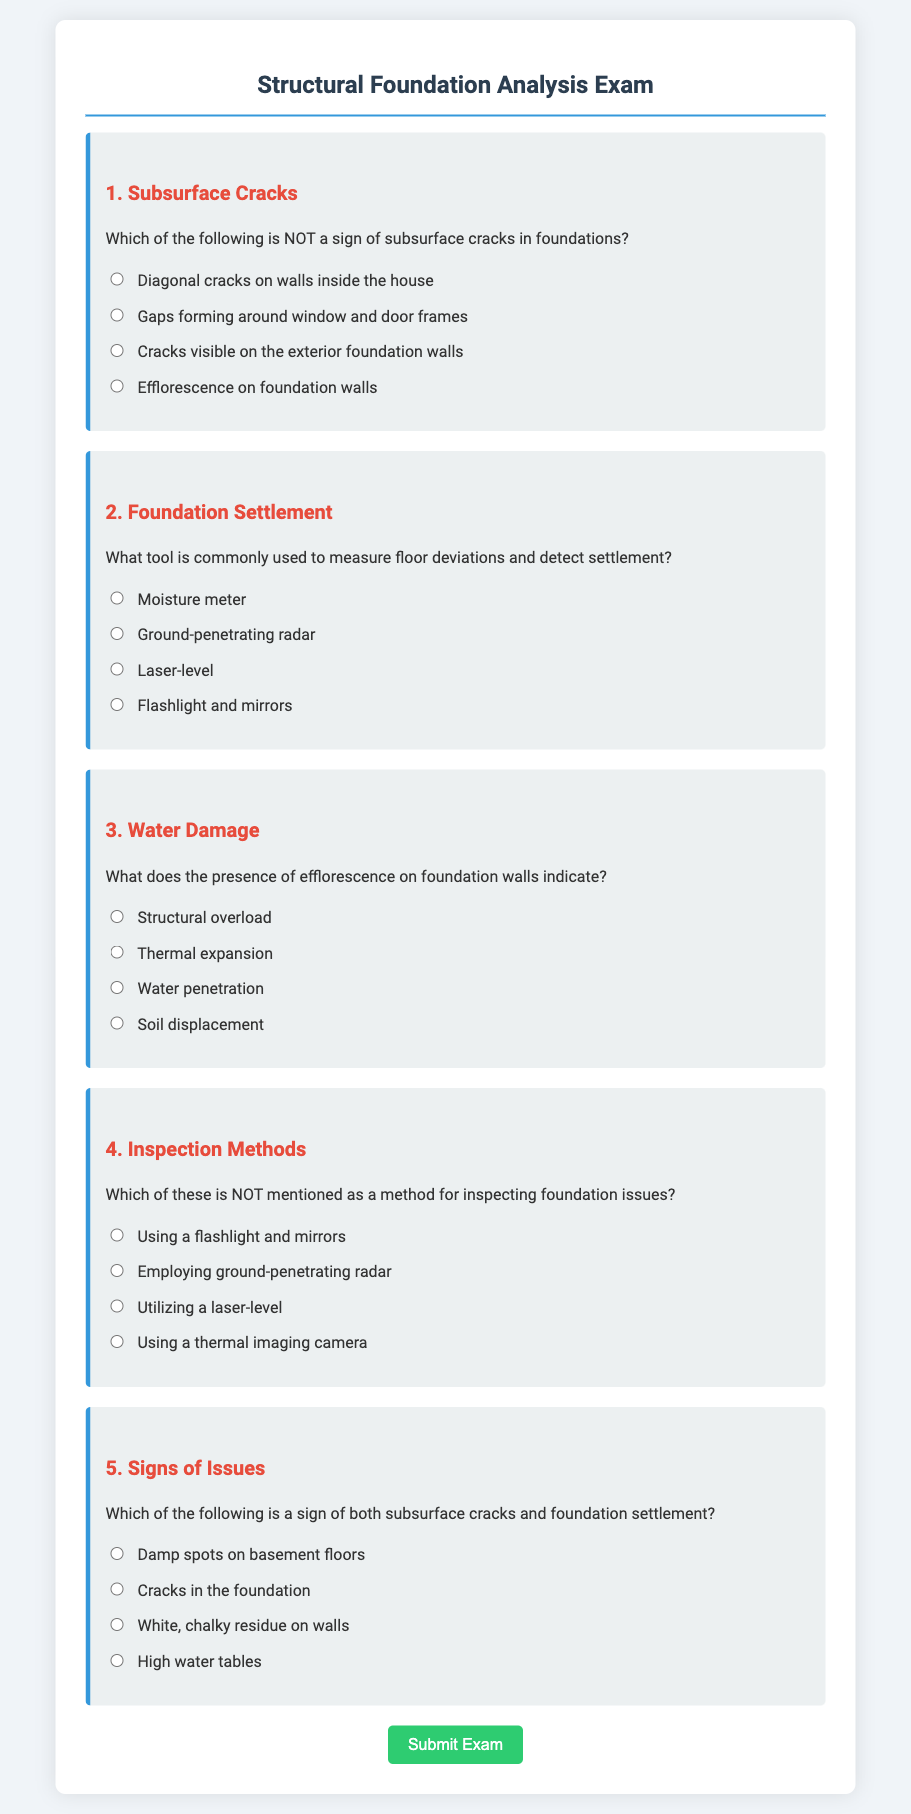What is the title of the document? The title is presented in the header of the document, which is "Structural Foundation Analysis Exam."
Answer: Structural Foundation Analysis Exam How many questions are in the exam? The exam contains five distinct questions outlined in the document.
Answer: 5 What is the main focus of question 3? Question 3 asks about the implications of efflorescence found on foundation walls.
Answer: Water penetration Which option is listed as a sign of subsurface cracks in foundations? One of the options under question 1 specifically states "Cracks visible on the exterior foundation walls" as a sign.
Answer: Cracks visible on the exterior foundation walls What inspection method is not mentioned in question 4? Question 4 asks for the method that is not included in the options and the correct answer is "Using a thermal imaging camera."
Answer: Using a thermal imaging camera Which tool is mentioned for measuring floor deviations? Question 2 highlights "Laser-level" as the tool used for measuring deviations and detecting settlement.
Answer: Laser-level What color is used for the question headings? The question headings utilize a red color for emphasis throughout the exam.
Answer: Red 